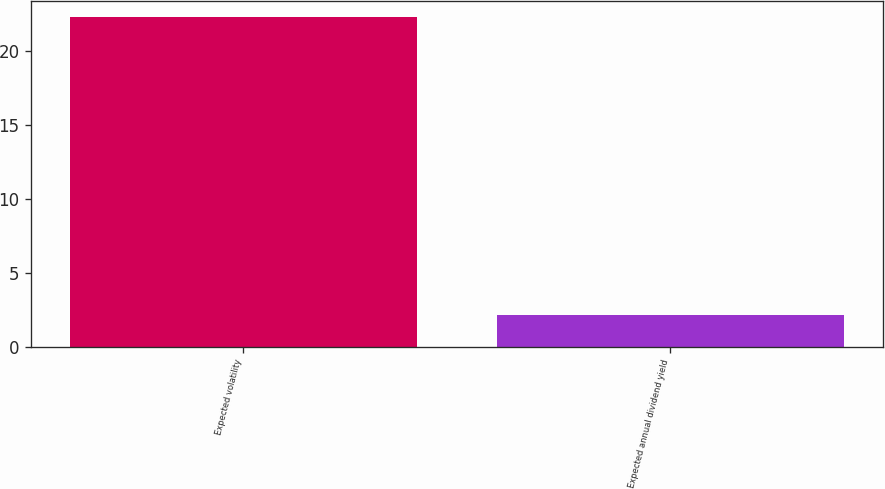Convert chart. <chart><loc_0><loc_0><loc_500><loc_500><bar_chart><fcel>Expected volatility<fcel>Expected annual dividend yield<nl><fcel>22.32<fcel>2.15<nl></chart> 